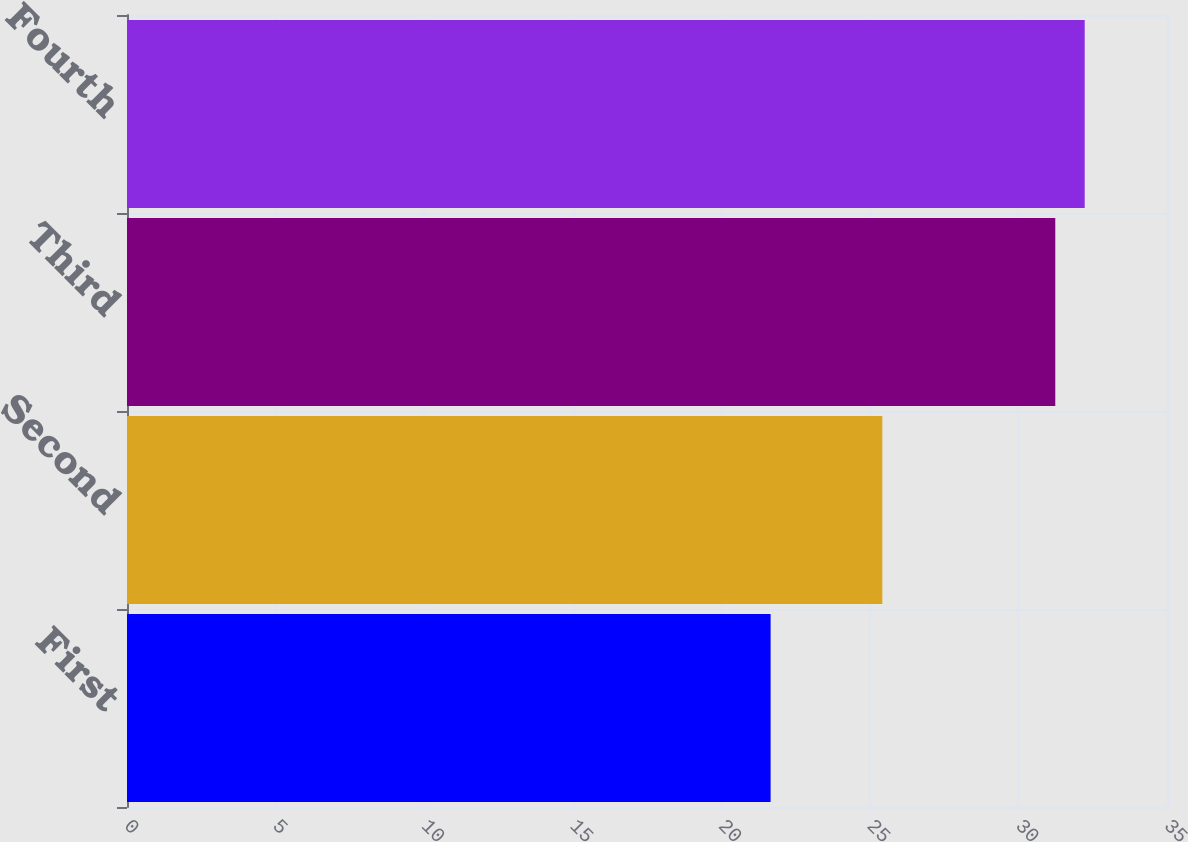<chart> <loc_0><loc_0><loc_500><loc_500><bar_chart><fcel>First<fcel>Second<fcel>Third<fcel>Fourth<nl><fcel>21.66<fcel>25.42<fcel>31.24<fcel>32.23<nl></chart> 